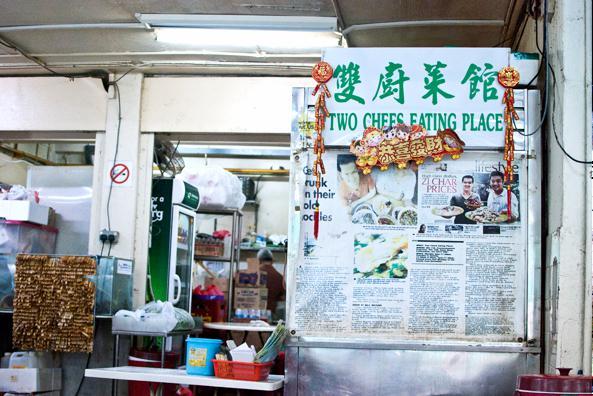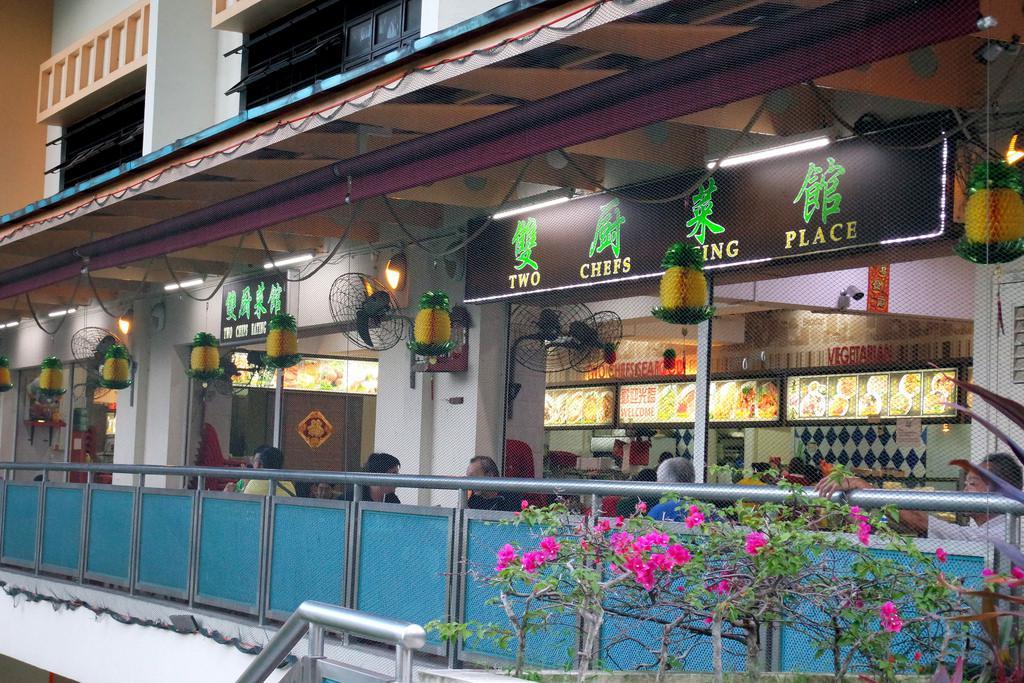The first image is the image on the left, the second image is the image on the right. Evaluate the accuracy of this statement regarding the images: "An image shows a diner with green Chinese characters on a black rectangle at the top front, and a row of lighted horizontal rectangles above a diamond-tile pattern in the background.". Is it true? Answer yes or no. Yes. The first image is the image on the left, the second image is the image on the right. Given the left and right images, does the statement "IN at least one image there is greenery next to an outside cafe." hold true? Answer yes or no. Yes. 